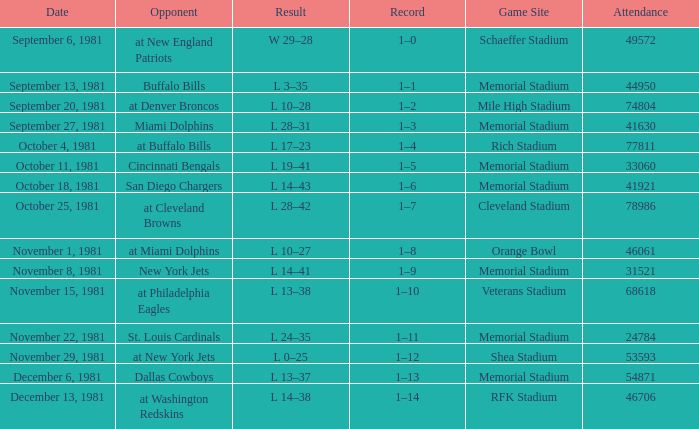Give me the full table as a dictionary. {'header': ['Date', 'Opponent', 'Result', 'Record', 'Game Site', 'Attendance'], 'rows': [['September 6, 1981', 'at New England Patriots', 'W 29–28', '1–0', 'Schaeffer Stadium', '49572'], ['September 13, 1981', 'Buffalo Bills', 'L 3–35', '1–1', 'Memorial Stadium', '44950'], ['September 20, 1981', 'at Denver Broncos', 'L 10–28', '1–2', 'Mile High Stadium', '74804'], ['September 27, 1981', 'Miami Dolphins', 'L 28–31', '1–3', 'Memorial Stadium', '41630'], ['October 4, 1981', 'at Buffalo Bills', 'L 17–23', '1–4', 'Rich Stadium', '77811'], ['October 11, 1981', 'Cincinnati Bengals', 'L 19–41', '1–5', 'Memorial Stadium', '33060'], ['October 18, 1981', 'San Diego Chargers', 'L 14–43', '1–6', 'Memorial Stadium', '41921'], ['October 25, 1981', 'at Cleveland Browns', 'L 28–42', '1–7', 'Cleveland Stadium', '78986'], ['November 1, 1981', 'at Miami Dolphins', 'L 10–27', '1–8', 'Orange Bowl', '46061'], ['November 8, 1981', 'New York Jets', 'L 14–41', '1–9', 'Memorial Stadium', '31521'], ['November 15, 1981', 'at Philadelphia Eagles', 'L 13–38', '1–10', 'Veterans Stadium', '68618'], ['November 22, 1981', 'St. Louis Cardinals', 'L 24–35', '1–11', 'Memorial Stadium', '24784'], ['November 29, 1981', 'at New York Jets', 'L 0–25', '1–12', 'Shea Stadium', '53593'], ['December 6, 1981', 'Dallas Cowboys', 'L 13–37', '1–13', 'Memorial Stadium', '54871'], ['December 13, 1981', 'at Washington Redskins', 'L 14–38', '1–14', 'RFK Stadium', '46706']]} On october 25, 1981, who was the adversary? At cleveland browns. 